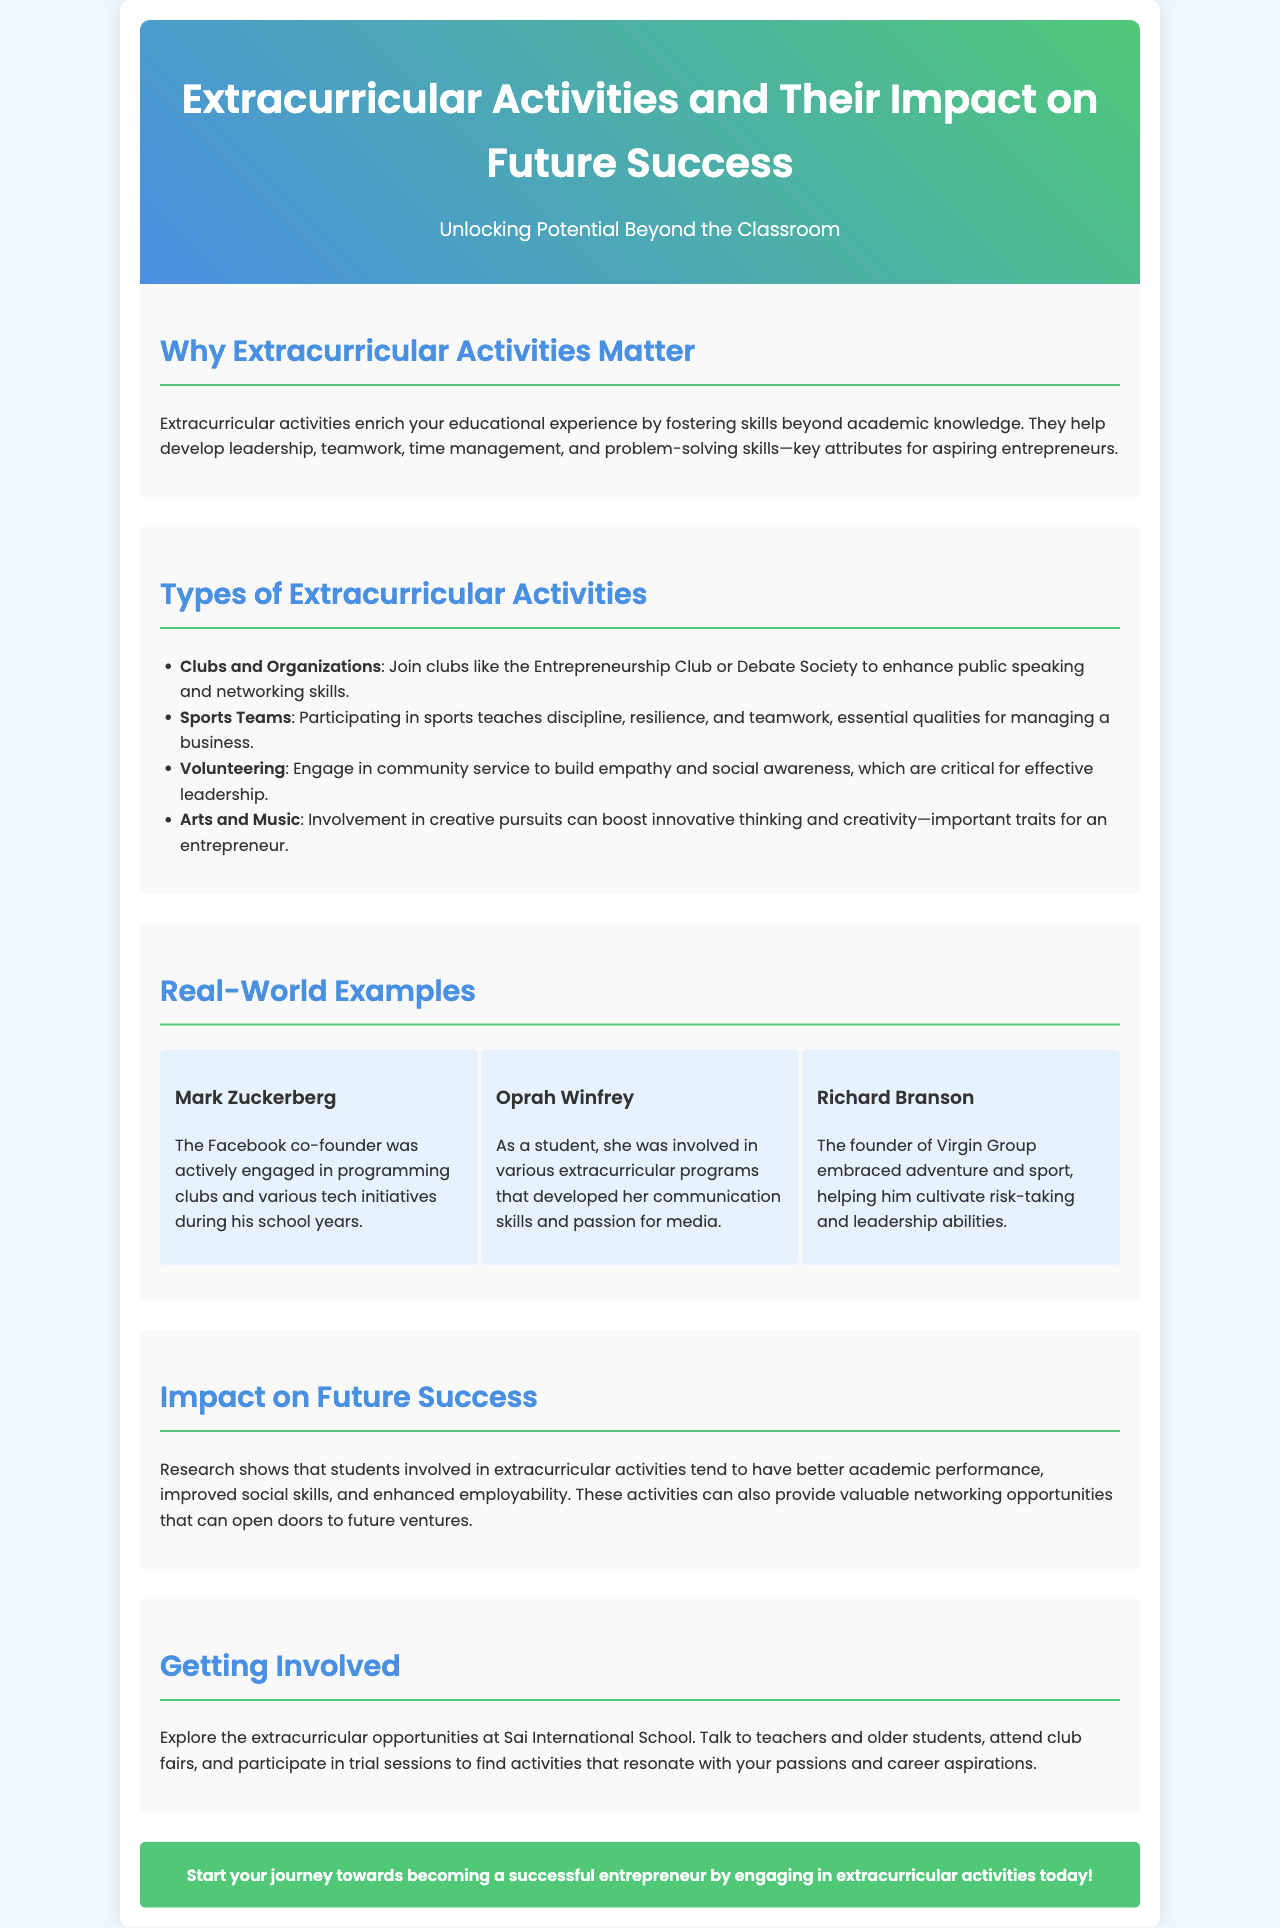What is the title of the brochure? The title is prominently displayed at the top of the document.
Answer: Extracurricular Activities and Their Impact on Future Success What are the four types of extracurricular activities listed? These are specified in a list within the document.
Answer: Clubs and Organizations, Sports Teams, Volunteering, Arts and Music Who is mentioned as a real-world example that was involved in programming clubs? The example is provided in a section about prominent individuals.
Answer: Mark Zuckerberg What impact do extracurricular activities have on academic performance? This is stated in the section about their impact on future success.
Answer: Better academic performance What are students encouraged to do to get involved? The document provides suggestions in the last section.
Answer: Explore the extracurricular opportunities at Sai International School 